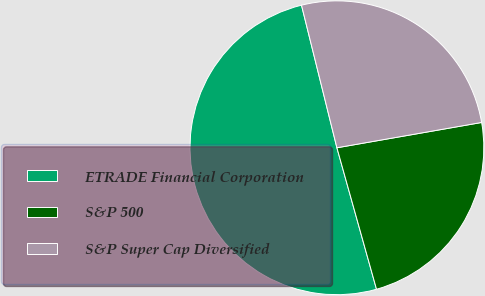Convert chart to OTSL. <chart><loc_0><loc_0><loc_500><loc_500><pie_chart><fcel>ETRADE Financial Corporation<fcel>S&P 500<fcel>S&P Super Cap Diversified<nl><fcel>50.47%<fcel>23.41%<fcel>26.12%<nl></chart> 